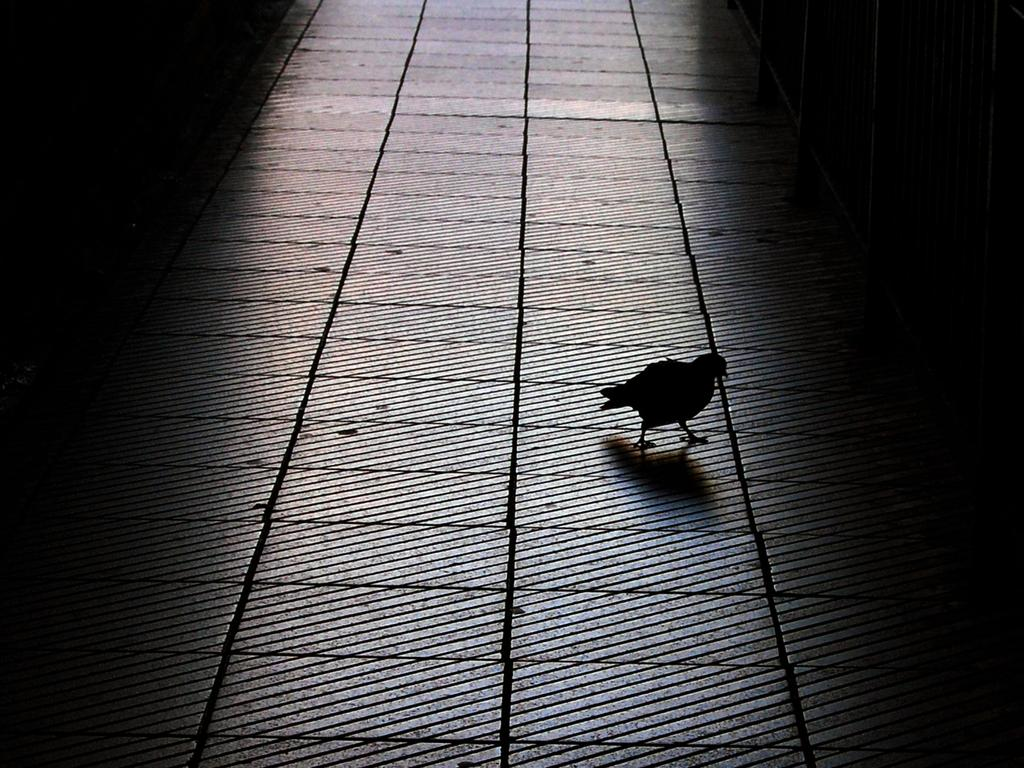What is the main subject in the middle of the image? There is a bird in the middle of the image. What can be seen beneath the bird? The floor is visible in the image. What type of brush is being used by the bird in the image? There is no brush present in the image, and the bird is not using any tool. 